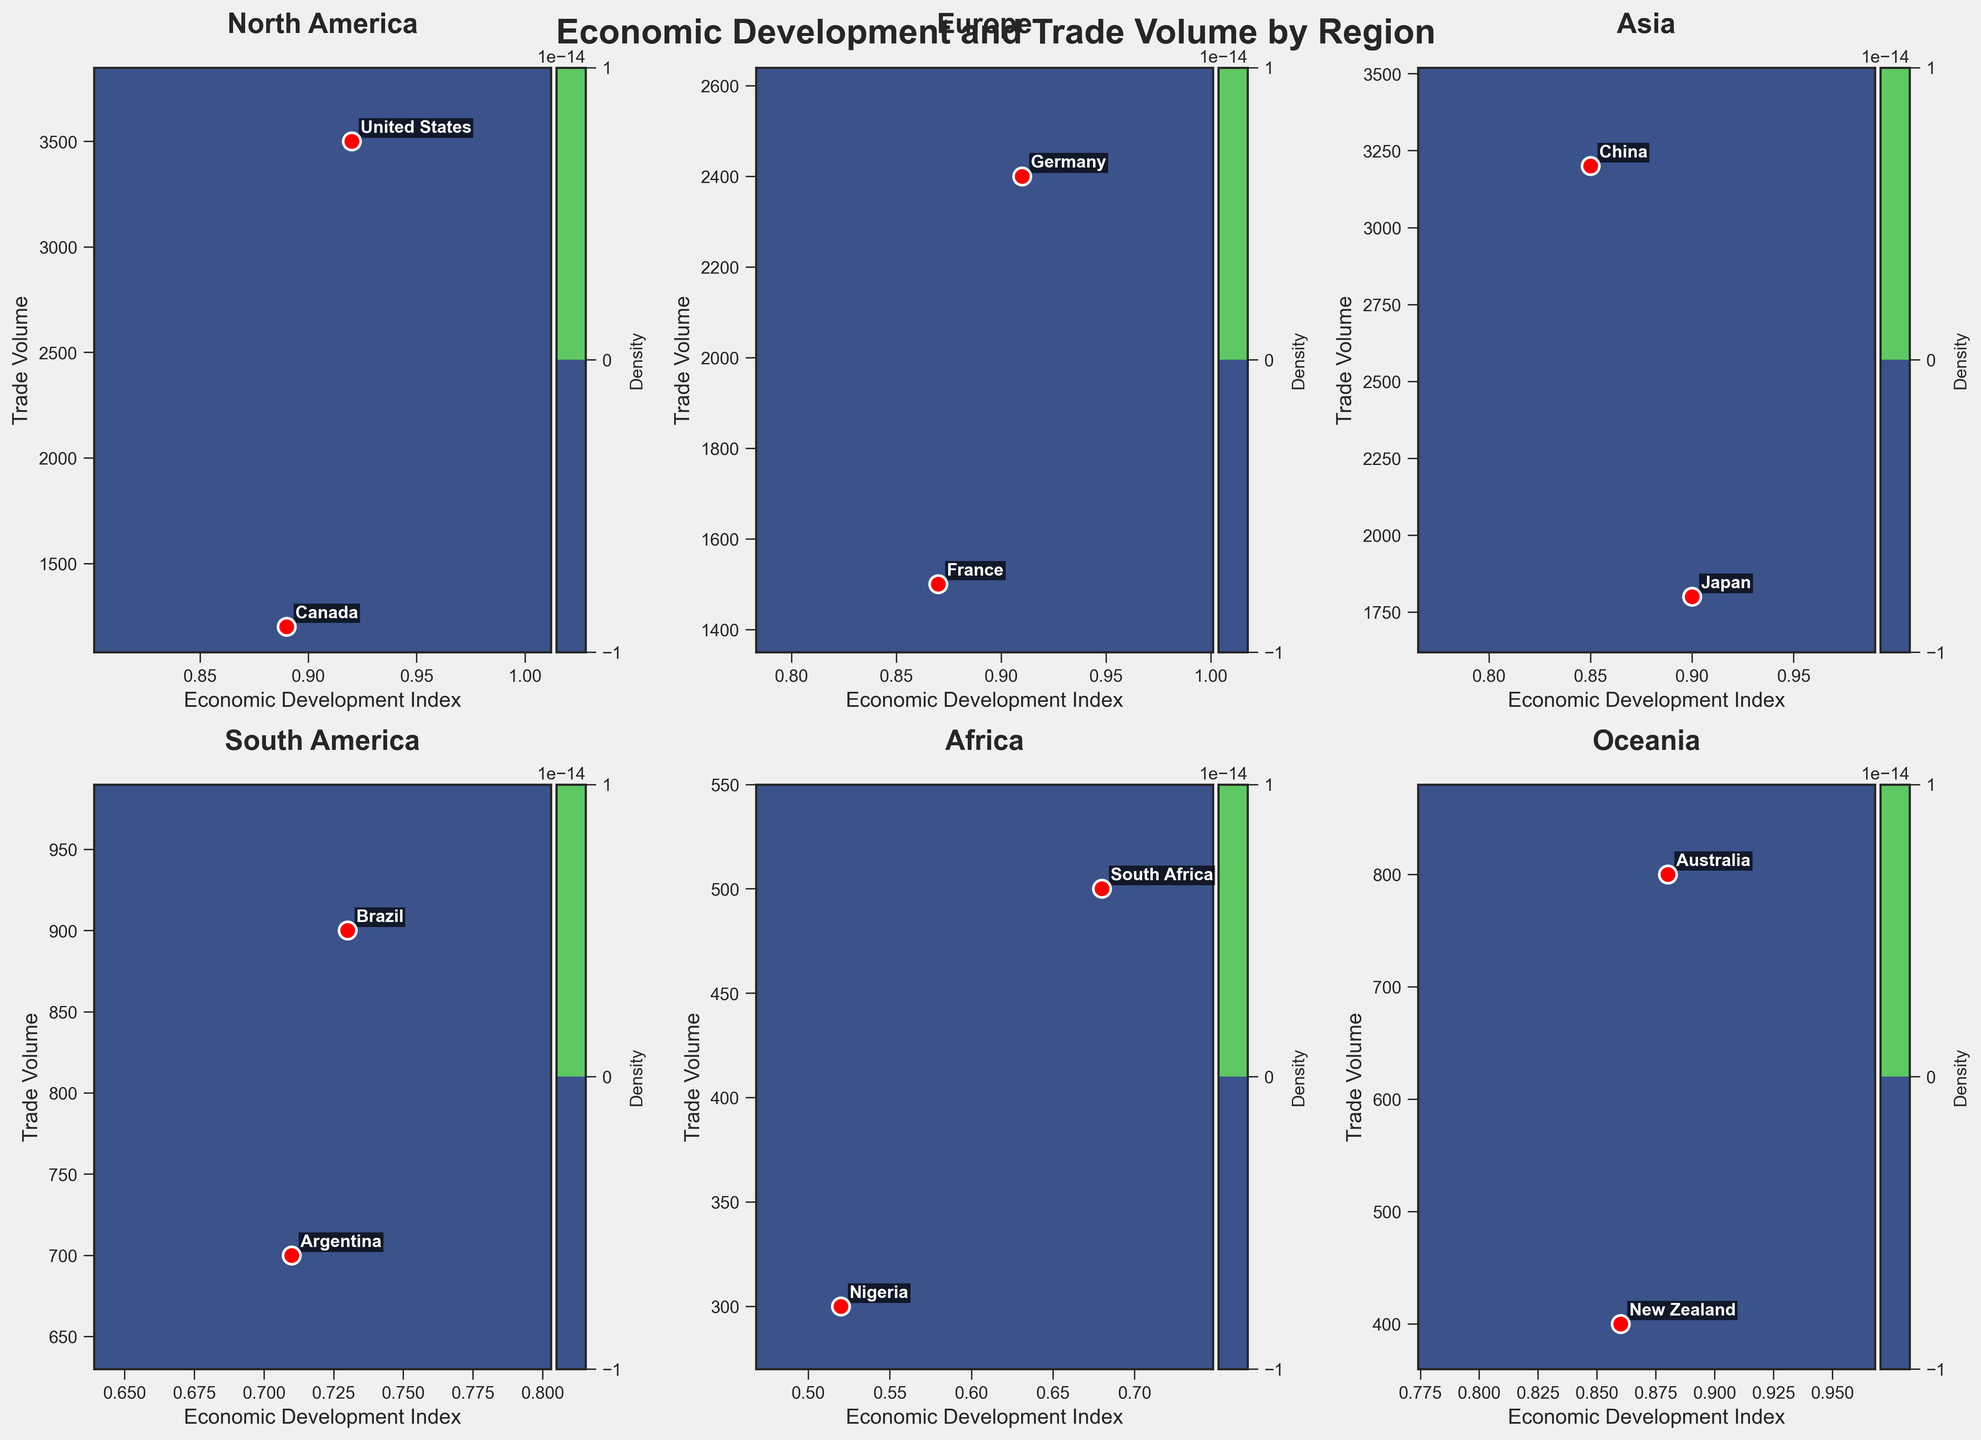What is the title of the figure? The title of the figure is located at the very top of the plot and should be clearly identifiable as the most prominent text.
Answer: Economic Development and Trade Volume by Region Which region shows the highest density in the contour plot? By observing the contour plots, the region with the highest density will have the darkest and most concentrated patches in the contour map.
Answer: North America How many data points are represented in the Africa subplot? Count the red scatter points within the Africa subplot to determine the number of data points.
Answer: 2 Which region has the country with the lowest Economic Development Index? By comparing the Economic Development Index values for each region, locate the lowest value.
Answer: Africa (Nigeria at 0.52) Which country in Oceania has a higher Trade Volume? Compare the Trade Volume values for the two countries represented in the Oceania subplot.
Answer: Australia In which region is the difference in Trade Volume between the countries the greatest? Calculate the differences in Trade Volume for each region and compare them. 
North America: 3500 - 1200 = 2300
Europe: 2400 - 1500 = 900
Asia: 3200 - 1800 = 1400
South America: 900 - 700 = 200
Africa: 500 - 300 = 200
Oceania: 800 - 400 = 400
Answer: North America What color represents the highest density areas in the contour plots? Identify the color used in the darkest and most concentrated areas of the contour plots in each subplot.
Answer: Dark purple Which region has the widest range of Economic Development Index in its subplot? Assess the range of Economic Development Index values in each subplot by subtracting the minimum value from the maximum value observed. 
North America: 0.92 - 0.89 = 0.03
Europe: 0.91 - 0.87 = 0.04
Asia: 0.90 - 0.85 = 0.05
South America: 0.73 - 0.71 = 0.02
Africa: 0.68 - 0.52 = 0.16
Oceania: 0.88 - 0.86 = 0.02
Answer: Africa Which country in South America has a higher Economic Development Index and by how much? Compare the Economic Development Index values for countries in South America and calculate the difference.
Brazil: 0.73
Argentina: 0.71
Difference: 0.73 - 0.71
Answer: Brazil by 0.02 